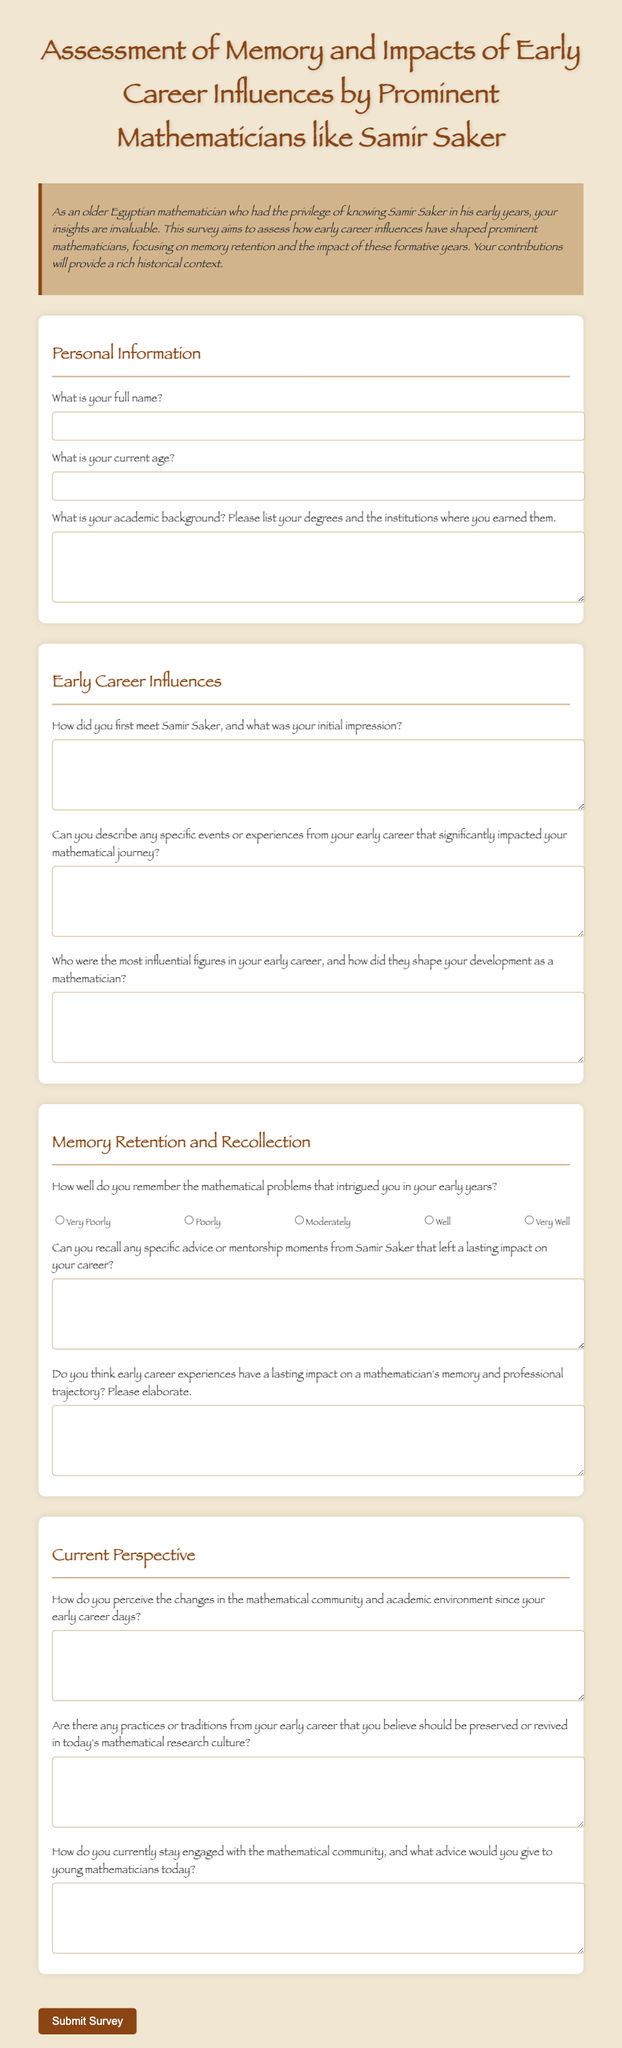What is the title of the survey? The title is stated at the top of the document, identifying the focus of the survey.
Answer: Assessment of Memory and Impacts of Early Career Influences by Prominent Mathematicians like Samir Saker What style of font is used in the document? The font family used for the document is specified in the CSS section, providing a unique appearance.
Answer: Papyrus What is asked in the question about Samir Saker? The survey includes a specific question regarding the first meeting and impression of Samir Saker.
Answer: How did you first meet Samir Saker, and what was your initial impression? How many sections are there in the survey? The document is structured into multiple distinct sections, facilitating a clear flow of information.
Answer: Four What type of feedback does the survey seek regarding early career experiences? The survey specifically asks for opinions and elaboration on the impact of early career experiences.
Answer: Do you think early career experiences have a lasting impact on a mathematician's memory and professional trajectory? Please elaborate What is the required input for the full name? There is a specific input field designated for gathering personal identification details from respondents.
Answer: What is your full name? 